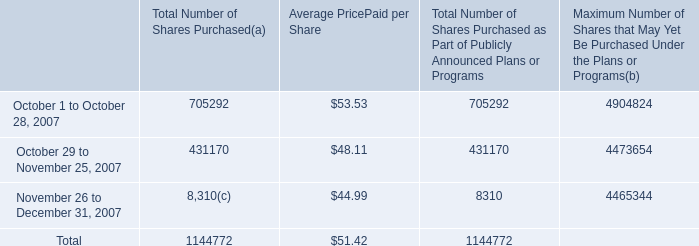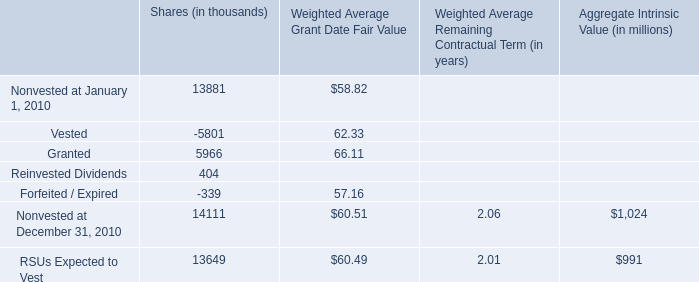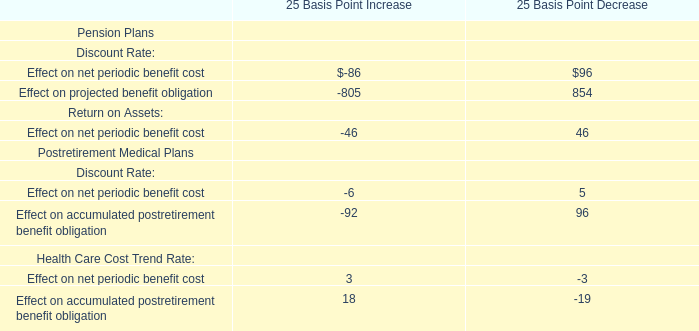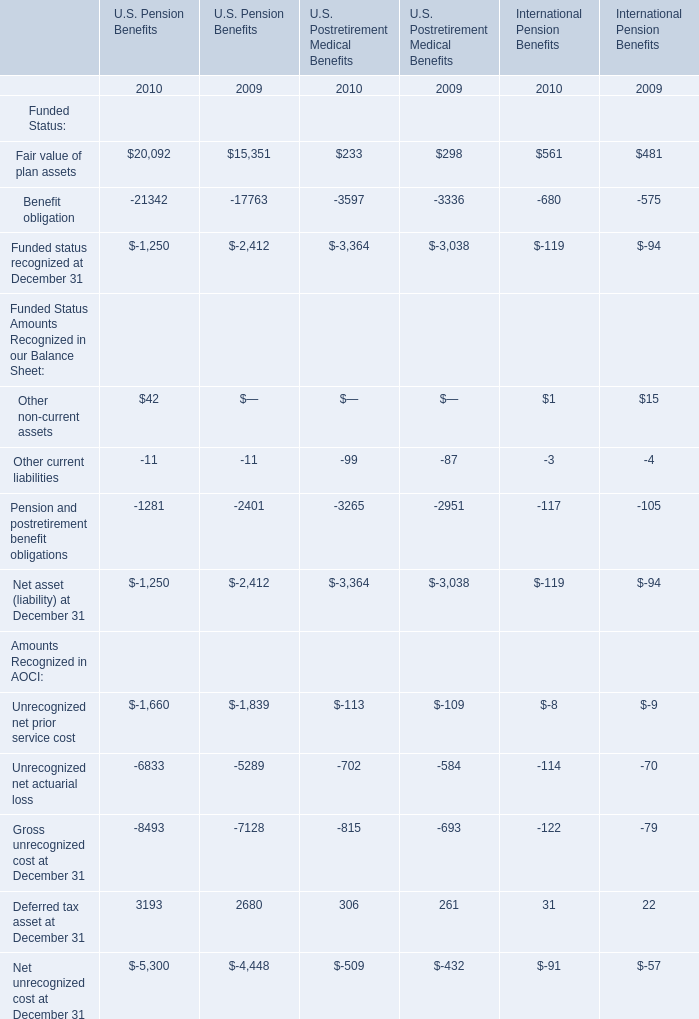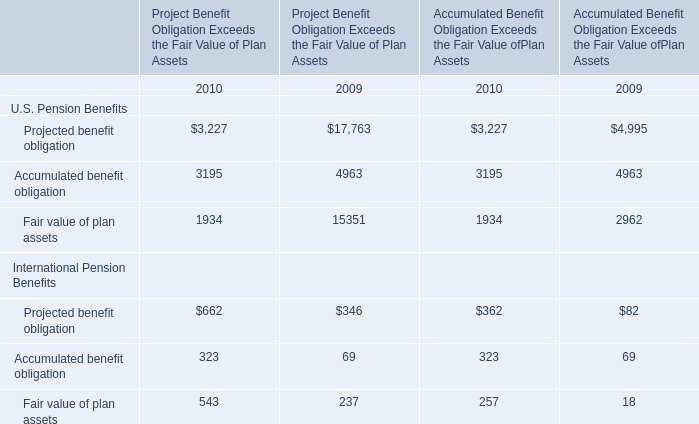what is the total amount of cash outflow used for shares repurchased during october 2007 , in millions? 
Computations: ((705292 * 53.53) / 1000000)
Answer: 37.75428. 